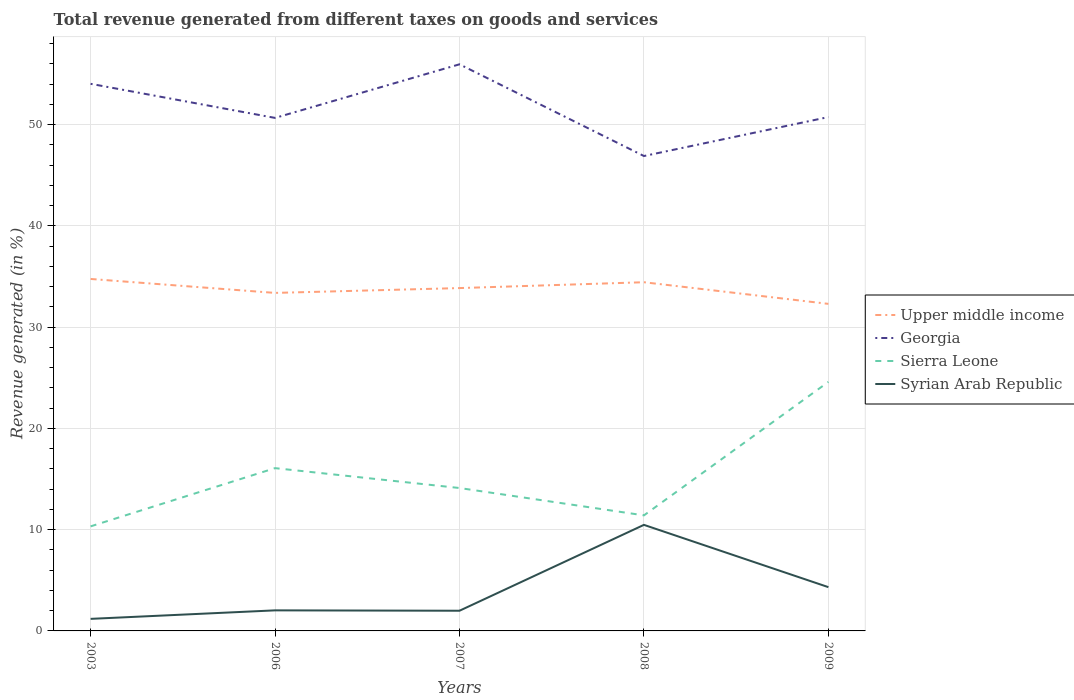Does the line corresponding to Sierra Leone intersect with the line corresponding to Georgia?
Give a very brief answer. No. Is the number of lines equal to the number of legend labels?
Offer a terse response. Yes. Across all years, what is the maximum total revenue generated in Georgia?
Your answer should be very brief. 46.89. In which year was the total revenue generated in Georgia maximum?
Keep it short and to the point. 2008. What is the total total revenue generated in Syrian Arab Republic in the graph?
Your answer should be compact. 0.04. What is the difference between the highest and the second highest total revenue generated in Upper middle income?
Provide a succinct answer. 2.46. How many years are there in the graph?
Offer a terse response. 5. Are the values on the major ticks of Y-axis written in scientific E-notation?
Give a very brief answer. No. Where does the legend appear in the graph?
Your response must be concise. Center right. What is the title of the graph?
Give a very brief answer. Total revenue generated from different taxes on goods and services. What is the label or title of the Y-axis?
Your answer should be compact. Revenue generated (in %). What is the Revenue generated (in %) of Upper middle income in 2003?
Give a very brief answer. 34.75. What is the Revenue generated (in %) of Georgia in 2003?
Ensure brevity in your answer.  54.02. What is the Revenue generated (in %) of Sierra Leone in 2003?
Offer a terse response. 10.32. What is the Revenue generated (in %) of Syrian Arab Republic in 2003?
Offer a terse response. 1.19. What is the Revenue generated (in %) of Upper middle income in 2006?
Your response must be concise. 33.38. What is the Revenue generated (in %) of Georgia in 2006?
Provide a short and direct response. 50.66. What is the Revenue generated (in %) of Sierra Leone in 2006?
Keep it short and to the point. 16.07. What is the Revenue generated (in %) of Syrian Arab Republic in 2006?
Your answer should be compact. 2.03. What is the Revenue generated (in %) of Upper middle income in 2007?
Ensure brevity in your answer.  33.85. What is the Revenue generated (in %) in Georgia in 2007?
Your answer should be very brief. 55.95. What is the Revenue generated (in %) in Sierra Leone in 2007?
Ensure brevity in your answer.  14.11. What is the Revenue generated (in %) in Syrian Arab Republic in 2007?
Provide a succinct answer. 1.99. What is the Revenue generated (in %) in Upper middle income in 2008?
Make the answer very short. 34.43. What is the Revenue generated (in %) of Georgia in 2008?
Your answer should be very brief. 46.89. What is the Revenue generated (in %) of Sierra Leone in 2008?
Offer a terse response. 11.41. What is the Revenue generated (in %) of Syrian Arab Republic in 2008?
Provide a short and direct response. 10.47. What is the Revenue generated (in %) in Upper middle income in 2009?
Offer a very short reply. 32.3. What is the Revenue generated (in %) in Georgia in 2009?
Your response must be concise. 50.74. What is the Revenue generated (in %) in Sierra Leone in 2009?
Give a very brief answer. 24.59. What is the Revenue generated (in %) of Syrian Arab Republic in 2009?
Your answer should be very brief. 4.32. Across all years, what is the maximum Revenue generated (in %) in Upper middle income?
Keep it short and to the point. 34.75. Across all years, what is the maximum Revenue generated (in %) in Georgia?
Your response must be concise. 55.95. Across all years, what is the maximum Revenue generated (in %) in Sierra Leone?
Your response must be concise. 24.59. Across all years, what is the maximum Revenue generated (in %) in Syrian Arab Republic?
Give a very brief answer. 10.47. Across all years, what is the minimum Revenue generated (in %) of Upper middle income?
Provide a short and direct response. 32.3. Across all years, what is the minimum Revenue generated (in %) in Georgia?
Offer a terse response. 46.89. Across all years, what is the minimum Revenue generated (in %) in Sierra Leone?
Your answer should be very brief. 10.32. Across all years, what is the minimum Revenue generated (in %) of Syrian Arab Republic?
Your response must be concise. 1.19. What is the total Revenue generated (in %) of Upper middle income in the graph?
Your answer should be very brief. 168.71. What is the total Revenue generated (in %) of Georgia in the graph?
Your answer should be compact. 258.27. What is the total Revenue generated (in %) in Sierra Leone in the graph?
Offer a terse response. 76.51. What is the total Revenue generated (in %) of Syrian Arab Republic in the graph?
Offer a very short reply. 20.01. What is the difference between the Revenue generated (in %) in Upper middle income in 2003 and that in 2006?
Give a very brief answer. 1.38. What is the difference between the Revenue generated (in %) of Georgia in 2003 and that in 2006?
Your answer should be very brief. 3.37. What is the difference between the Revenue generated (in %) of Sierra Leone in 2003 and that in 2006?
Give a very brief answer. -5.75. What is the difference between the Revenue generated (in %) of Syrian Arab Republic in 2003 and that in 2006?
Provide a short and direct response. -0.84. What is the difference between the Revenue generated (in %) of Upper middle income in 2003 and that in 2007?
Offer a terse response. 0.9. What is the difference between the Revenue generated (in %) of Georgia in 2003 and that in 2007?
Your response must be concise. -1.93. What is the difference between the Revenue generated (in %) of Sierra Leone in 2003 and that in 2007?
Your answer should be compact. -3.79. What is the difference between the Revenue generated (in %) in Syrian Arab Republic in 2003 and that in 2007?
Your answer should be very brief. -0.8. What is the difference between the Revenue generated (in %) of Upper middle income in 2003 and that in 2008?
Offer a terse response. 0.32. What is the difference between the Revenue generated (in %) of Georgia in 2003 and that in 2008?
Offer a terse response. 7.13. What is the difference between the Revenue generated (in %) of Sierra Leone in 2003 and that in 2008?
Your answer should be very brief. -1.09. What is the difference between the Revenue generated (in %) in Syrian Arab Republic in 2003 and that in 2008?
Ensure brevity in your answer.  -9.28. What is the difference between the Revenue generated (in %) in Upper middle income in 2003 and that in 2009?
Ensure brevity in your answer.  2.46. What is the difference between the Revenue generated (in %) of Georgia in 2003 and that in 2009?
Provide a succinct answer. 3.28. What is the difference between the Revenue generated (in %) in Sierra Leone in 2003 and that in 2009?
Provide a succinct answer. -14.27. What is the difference between the Revenue generated (in %) of Syrian Arab Republic in 2003 and that in 2009?
Keep it short and to the point. -3.13. What is the difference between the Revenue generated (in %) of Upper middle income in 2006 and that in 2007?
Provide a short and direct response. -0.48. What is the difference between the Revenue generated (in %) in Georgia in 2006 and that in 2007?
Ensure brevity in your answer.  -5.29. What is the difference between the Revenue generated (in %) of Sierra Leone in 2006 and that in 2007?
Your answer should be very brief. 1.96. What is the difference between the Revenue generated (in %) in Syrian Arab Republic in 2006 and that in 2007?
Your response must be concise. 0.04. What is the difference between the Revenue generated (in %) of Upper middle income in 2006 and that in 2008?
Offer a very short reply. -1.05. What is the difference between the Revenue generated (in %) in Georgia in 2006 and that in 2008?
Offer a terse response. 3.76. What is the difference between the Revenue generated (in %) in Sierra Leone in 2006 and that in 2008?
Make the answer very short. 4.66. What is the difference between the Revenue generated (in %) of Syrian Arab Republic in 2006 and that in 2008?
Ensure brevity in your answer.  -8.44. What is the difference between the Revenue generated (in %) of Upper middle income in 2006 and that in 2009?
Offer a very short reply. 1.08. What is the difference between the Revenue generated (in %) of Georgia in 2006 and that in 2009?
Make the answer very short. -0.08. What is the difference between the Revenue generated (in %) in Sierra Leone in 2006 and that in 2009?
Make the answer very short. -8.52. What is the difference between the Revenue generated (in %) in Syrian Arab Republic in 2006 and that in 2009?
Your answer should be compact. -2.29. What is the difference between the Revenue generated (in %) in Upper middle income in 2007 and that in 2008?
Offer a terse response. -0.58. What is the difference between the Revenue generated (in %) in Georgia in 2007 and that in 2008?
Offer a very short reply. 9.06. What is the difference between the Revenue generated (in %) in Sierra Leone in 2007 and that in 2008?
Your answer should be very brief. 2.7. What is the difference between the Revenue generated (in %) in Syrian Arab Republic in 2007 and that in 2008?
Give a very brief answer. -8.48. What is the difference between the Revenue generated (in %) of Upper middle income in 2007 and that in 2009?
Ensure brevity in your answer.  1.56. What is the difference between the Revenue generated (in %) of Georgia in 2007 and that in 2009?
Your answer should be compact. 5.21. What is the difference between the Revenue generated (in %) in Sierra Leone in 2007 and that in 2009?
Give a very brief answer. -10.48. What is the difference between the Revenue generated (in %) in Syrian Arab Republic in 2007 and that in 2009?
Offer a terse response. -2.33. What is the difference between the Revenue generated (in %) of Upper middle income in 2008 and that in 2009?
Ensure brevity in your answer.  2.14. What is the difference between the Revenue generated (in %) of Georgia in 2008 and that in 2009?
Make the answer very short. -3.85. What is the difference between the Revenue generated (in %) in Sierra Leone in 2008 and that in 2009?
Offer a very short reply. -13.18. What is the difference between the Revenue generated (in %) of Syrian Arab Republic in 2008 and that in 2009?
Give a very brief answer. 6.15. What is the difference between the Revenue generated (in %) of Upper middle income in 2003 and the Revenue generated (in %) of Georgia in 2006?
Your answer should be very brief. -15.9. What is the difference between the Revenue generated (in %) in Upper middle income in 2003 and the Revenue generated (in %) in Sierra Leone in 2006?
Provide a succinct answer. 18.68. What is the difference between the Revenue generated (in %) in Upper middle income in 2003 and the Revenue generated (in %) in Syrian Arab Republic in 2006?
Make the answer very short. 32.72. What is the difference between the Revenue generated (in %) of Georgia in 2003 and the Revenue generated (in %) of Sierra Leone in 2006?
Offer a terse response. 37.95. What is the difference between the Revenue generated (in %) in Georgia in 2003 and the Revenue generated (in %) in Syrian Arab Republic in 2006?
Ensure brevity in your answer.  51.99. What is the difference between the Revenue generated (in %) in Sierra Leone in 2003 and the Revenue generated (in %) in Syrian Arab Republic in 2006?
Your answer should be compact. 8.29. What is the difference between the Revenue generated (in %) in Upper middle income in 2003 and the Revenue generated (in %) in Georgia in 2007?
Keep it short and to the point. -21.2. What is the difference between the Revenue generated (in %) in Upper middle income in 2003 and the Revenue generated (in %) in Sierra Leone in 2007?
Make the answer very short. 20.64. What is the difference between the Revenue generated (in %) of Upper middle income in 2003 and the Revenue generated (in %) of Syrian Arab Republic in 2007?
Your answer should be very brief. 32.76. What is the difference between the Revenue generated (in %) of Georgia in 2003 and the Revenue generated (in %) of Sierra Leone in 2007?
Ensure brevity in your answer.  39.91. What is the difference between the Revenue generated (in %) in Georgia in 2003 and the Revenue generated (in %) in Syrian Arab Republic in 2007?
Offer a terse response. 52.03. What is the difference between the Revenue generated (in %) of Sierra Leone in 2003 and the Revenue generated (in %) of Syrian Arab Republic in 2007?
Your answer should be compact. 8.33. What is the difference between the Revenue generated (in %) of Upper middle income in 2003 and the Revenue generated (in %) of Georgia in 2008?
Your answer should be compact. -12.14. What is the difference between the Revenue generated (in %) in Upper middle income in 2003 and the Revenue generated (in %) in Sierra Leone in 2008?
Your answer should be very brief. 23.34. What is the difference between the Revenue generated (in %) in Upper middle income in 2003 and the Revenue generated (in %) in Syrian Arab Republic in 2008?
Keep it short and to the point. 24.28. What is the difference between the Revenue generated (in %) in Georgia in 2003 and the Revenue generated (in %) in Sierra Leone in 2008?
Provide a short and direct response. 42.61. What is the difference between the Revenue generated (in %) of Georgia in 2003 and the Revenue generated (in %) of Syrian Arab Republic in 2008?
Keep it short and to the point. 43.55. What is the difference between the Revenue generated (in %) of Sierra Leone in 2003 and the Revenue generated (in %) of Syrian Arab Republic in 2008?
Provide a short and direct response. -0.15. What is the difference between the Revenue generated (in %) in Upper middle income in 2003 and the Revenue generated (in %) in Georgia in 2009?
Offer a very short reply. -15.99. What is the difference between the Revenue generated (in %) of Upper middle income in 2003 and the Revenue generated (in %) of Sierra Leone in 2009?
Give a very brief answer. 10.16. What is the difference between the Revenue generated (in %) in Upper middle income in 2003 and the Revenue generated (in %) in Syrian Arab Republic in 2009?
Provide a short and direct response. 30.43. What is the difference between the Revenue generated (in %) in Georgia in 2003 and the Revenue generated (in %) in Sierra Leone in 2009?
Make the answer very short. 29.43. What is the difference between the Revenue generated (in %) of Georgia in 2003 and the Revenue generated (in %) of Syrian Arab Republic in 2009?
Make the answer very short. 49.7. What is the difference between the Revenue generated (in %) in Sierra Leone in 2003 and the Revenue generated (in %) in Syrian Arab Republic in 2009?
Keep it short and to the point. 6. What is the difference between the Revenue generated (in %) in Upper middle income in 2006 and the Revenue generated (in %) in Georgia in 2007?
Your response must be concise. -22.57. What is the difference between the Revenue generated (in %) in Upper middle income in 2006 and the Revenue generated (in %) in Sierra Leone in 2007?
Offer a terse response. 19.27. What is the difference between the Revenue generated (in %) of Upper middle income in 2006 and the Revenue generated (in %) of Syrian Arab Republic in 2007?
Provide a short and direct response. 31.38. What is the difference between the Revenue generated (in %) of Georgia in 2006 and the Revenue generated (in %) of Sierra Leone in 2007?
Ensure brevity in your answer.  36.55. What is the difference between the Revenue generated (in %) of Georgia in 2006 and the Revenue generated (in %) of Syrian Arab Republic in 2007?
Give a very brief answer. 48.66. What is the difference between the Revenue generated (in %) of Sierra Leone in 2006 and the Revenue generated (in %) of Syrian Arab Republic in 2007?
Provide a short and direct response. 14.08. What is the difference between the Revenue generated (in %) in Upper middle income in 2006 and the Revenue generated (in %) in Georgia in 2008?
Give a very brief answer. -13.52. What is the difference between the Revenue generated (in %) of Upper middle income in 2006 and the Revenue generated (in %) of Sierra Leone in 2008?
Give a very brief answer. 21.97. What is the difference between the Revenue generated (in %) in Upper middle income in 2006 and the Revenue generated (in %) in Syrian Arab Republic in 2008?
Your response must be concise. 22.9. What is the difference between the Revenue generated (in %) in Georgia in 2006 and the Revenue generated (in %) in Sierra Leone in 2008?
Your answer should be compact. 39.25. What is the difference between the Revenue generated (in %) in Georgia in 2006 and the Revenue generated (in %) in Syrian Arab Republic in 2008?
Ensure brevity in your answer.  40.18. What is the difference between the Revenue generated (in %) in Sierra Leone in 2006 and the Revenue generated (in %) in Syrian Arab Republic in 2008?
Offer a terse response. 5.6. What is the difference between the Revenue generated (in %) of Upper middle income in 2006 and the Revenue generated (in %) of Georgia in 2009?
Your answer should be compact. -17.36. What is the difference between the Revenue generated (in %) of Upper middle income in 2006 and the Revenue generated (in %) of Sierra Leone in 2009?
Provide a short and direct response. 8.79. What is the difference between the Revenue generated (in %) of Upper middle income in 2006 and the Revenue generated (in %) of Syrian Arab Republic in 2009?
Offer a very short reply. 29.05. What is the difference between the Revenue generated (in %) in Georgia in 2006 and the Revenue generated (in %) in Sierra Leone in 2009?
Your response must be concise. 26.07. What is the difference between the Revenue generated (in %) of Georgia in 2006 and the Revenue generated (in %) of Syrian Arab Republic in 2009?
Your answer should be very brief. 46.34. What is the difference between the Revenue generated (in %) of Sierra Leone in 2006 and the Revenue generated (in %) of Syrian Arab Republic in 2009?
Give a very brief answer. 11.75. What is the difference between the Revenue generated (in %) in Upper middle income in 2007 and the Revenue generated (in %) in Georgia in 2008?
Provide a short and direct response. -13.04. What is the difference between the Revenue generated (in %) in Upper middle income in 2007 and the Revenue generated (in %) in Sierra Leone in 2008?
Provide a short and direct response. 22.44. What is the difference between the Revenue generated (in %) of Upper middle income in 2007 and the Revenue generated (in %) of Syrian Arab Republic in 2008?
Provide a succinct answer. 23.38. What is the difference between the Revenue generated (in %) in Georgia in 2007 and the Revenue generated (in %) in Sierra Leone in 2008?
Keep it short and to the point. 44.54. What is the difference between the Revenue generated (in %) in Georgia in 2007 and the Revenue generated (in %) in Syrian Arab Republic in 2008?
Your answer should be very brief. 45.48. What is the difference between the Revenue generated (in %) of Sierra Leone in 2007 and the Revenue generated (in %) of Syrian Arab Republic in 2008?
Offer a terse response. 3.64. What is the difference between the Revenue generated (in %) in Upper middle income in 2007 and the Revenue generated (in %) in Georgia in 2009?
Offer a terse response. -16.89. What is the difference between the Revenue generated (in %) of Upper middle income in 2007 and the Revenue generated (in %) of Sierra Leone in 2009?
Give a very brief answer. 9.26. What is the difference between the Revenue generated (in %) in Upper middle income in 2007 and the Revenue generated (in %) in Syrian Arab Republic in 2009?
Make the answer very short. 29.53. What is the difference between the Revenue generated (in %) in Georgia in 2007 and the Revenue generated (in %) in Sierra Leone in 2009?
Keep it short and to the point. 31.36. What is the difference between the Revenue generated (in %) of Georgia in 2007 and the Revenue generated (in %) of Syrian Arab Republic in 2009?
Your answer should be very brief. 51.63. What is the difference between the Revenue generated (in %) of Sierra Leone in 2007 and the Revenue generated (in %) of Syrian Arab Republic in 2009?
Keep it short and to the point. 9.79. What is the difference between the Revenue generated (in %) in Upper middle income in 2008 and the Revenue generated (in %) in Georgia in 2009?
Your response must be concise. -16.31. What is the difference between the Revenue generated (in %) of Upper middle income in 2008 and the Revenue generated (in %) of Sierra Leone in 2009?
Ensure brevity in your answer.  9.84. What is the difference between the Revenue generated (in %) of Upper middle income in 2008 and the Revenue generated (in %) of Syrian Arab Republic in 2009?
Offer a terse response. 30.11. What is the difference between the Revenue generated (in %) of Georgia in 2008 and the Revenue generated (in %) of Sierra Leone in 2009?
Offer a very short reply. 22.3. What is the difference between the Revenue generated (in %) in Georgia in 2008 and the Revenue generated (in %) in Syrian Arab Republic in 2009?
Keep it short and to the point. 42.57. What is the difference between the Revenue generated (in %) of Sierra Leone in 2008 and the Revenue generated (in %) of Syrian Arab Republic in 2009?
Give a very brief answer. 7.09. What is the average Revenue generated (in %) of Upper middle income per year?
Your answer should be very brief. 33.74. What is the average Revenue generated (in %) in Georgia per year?
Provide a short and direct response. 51.65. What is the average Revenue generated (in %) of Sierra Leone per year?
Offer a terse response. 15.3. What is the average Revenue generated (in %) of Syrian Arab Republic per year?
Ensure brevity in your answer.  4. In the year 2003, what is the difference between the Revenue generated (in %) in Upper middle income and Revenue generated (in %) in Georgia?
Provide a short and direct response. -19.27. In the year 2003, what is the difference between the Revenue generated (in %) of Upper middle income and Revenue generated (in %) of Sierra Leone?
Make the answer very short. 24.43. In the year 2003, what is the difference between the Revenue generated (in %) in Upper middle income and Revenue generated (in %) in Syrian Arab Republic?
Your answer should be compact. 33.56. In the year 2003, what is the difference between the Revenue generated (in %) of Georgia and Revenue generated (in %) of Sierra Leone?
Make the answer very short. 43.7. In the year 2003, what is the difference between the Revenue generated (in %) of Georgia and Revenue generated (in %) of Syrian Arab Republic?
Your answer should be compact. 52.83. In the year 2003, what is the difference between the Revenue generated (in %) of Sierra Leone and Revenue generated (in %) of Syrian Arab Republic?
Offer a very short reply. 9.13. In the year 2006, what is the difference between the Revenue generated (in %) in Upper middle income and Revenue generated (in %) in Georgia?
Keep it short and to the point. -17.28. In the year 2006, what is the difference between the Revenue generated (in %) of Upper middle income and Revenue generated (in %) of Sierra Leone?
Your answer should be very brief. 17.3. In the year 2006, what is the difference between the Revenue generated (in %) of Upper middle income and Revenue generated (in %) of Syrian Arab Republic?
Offer a terse response. 31.35. In the year 2006, what is the difference between the Revenue generated (in %) of Georgia and Revenue generated (in %) of Sierra Leone?
Your answer should be compact. 34.58. In the year 2006, what is the difference between the Revenue generated (in %) of Georgia and Revenue generated (in %) of Syrian Arab Republic?
Provide a short and direct response. 48.63. In the year 2006, what is the difference between the Revenue generated (in %) in Sierra Leone and Revenue generated (in %) in Syrian Arab Republic?
Ensure brevity in your answer.  14.04. In the year 2007, what is the difference between the Revenue generated (in %) in Upper middle income and Revenue generated (in %) in Georgia?
Your answer should be compact. -22.1. In the year 2007, what is the difference between the Revenue generated (in %) of Upper middle income and Revenue generated (in %) of Sierra Leone?
Keep it short and to the point. 19.74. In the year 2007, what is the difference between the Revenue generated (in %) in Upper middle income and Revenue generated (in %) in Syrian Arab Republic?
Offer a very short reply. 31.86. In the year 2007, what is the difference between the Revenue generated (in %) in Georgia and Revenue generated (in %) in Sierra Leone?
Make the answer very short. 41.84. In the year 2007, what is the difference between the Revenue generated (in %) of Georgia and Revenue generated (in %) of Syrian Arab Republic?
Give a very brief answer. 53.96. In the year 2007, what is the difference between the Revenue generated (in %) of Sierra Leone and Revenue generated (in %) of Syrian Arab Republic?
Offer a terse response. 12.12. In the year 2008, what is the difference between the Revenue generated (in %) of Upper middle income and Revenue generated (in %) of Georgia?
Your response must be concise. -12.46. In the year 2008, what is the difference between the Revenue generated (in %) in Upper middle income and Revenue generated (in %) in Sierra Leone?
Your answer should be compact. 23.02. In the year 2008, what is the difference between the Revenue generated (in %) of Upper middle income and Revenue generated (in %) of Syrian Arab Republic?
Your response must be concise. 23.96. In the year 2008, what is the difference between the Revenue generated (in %) of Georgia and Revenue generated (in %) of Sierra Leone?
Keep it short and to the point. 35.48. In the year 2008, what is the difference between the Revenue generated (in %) in Georgia and Revenue generated (in %) in Syrian Arab Republic?
Keep it short and to the point. 36.42. In the year 2008, what is the difference between the Revenue generated (in %) of Sierra Leone and Revenue generated (in %) of Syrian Arab Republic?
Offer a terse response. 0.94. In the year 2009, what is the difference between the Revenue generated (in %) in Upper middle income and Revenue generated (in %) in Georgia?
Give a very brief answer. -18.44. In the year 2009, what is the difference between the Revenue generated (in %) in Upper middle income and Revenue generated (in %) in Sierra Leone?
Your response must be concise. 7.7. In the year 2009, what is the difference between the Revenue generated (in %) of Upper middle income and Revenue generated (in %) of Syrian Arab Republic?
Provide a succinct answer. 27.97. In the year 2009, what is the difference between the Revenue generated (in %) in Georgia and Revenue generated (in %) in Sierra Leone?
Make the answer very short. 26.15. In the year 2009, what is the difference between the Revenue generated (in %) in Georgia and Revenue generated (in %) in Syrian Arab Republic?
Offer a very short reply. 46.42. In the year 2009, what is the difference between the Revenue generated (in %) in Sierra Leone and Revenue generated (in %) in Syrian Arab Republic?
Offer a very short reply. 20.27. What is the ratio of the Revenue generated (in %) of Upper middle income in 2003 to that in 2006?
Your answer should be compact. 1.04. What is the ratio of the Revenue generated (in %) in Georgia in 2003 to that in 2006?
Your response must be concise. 1.07. What is the ratio of the Revenue generated (in %) of Sierra Leone in 2003 to that in 2006?
Keep it short and to the point. 0.64. What is the ratio of the Revenue generated (in %) in Syrian Arab Republic in 2003 to that in 2006?
Give a very brief answer. 0.59. What is the ratio of the Revenue generated (in %) of Upper middle income in 2003 to that in 2007?
Your answer should be compact. 1.03. What is the ratio of the Revenue generated (in %) of Georgia in 2003 to that in 2007?
Provide a succinct answer. 0.97. What is the ratio of the Revenue generated (in %) in Sierra Leone in 2003 to that in 2007?
Give a very brief answer. 0.73. What is the ratio of the Revenue generated (in %) in Syrian Arab Republic in 2003 to that in 2007?
Provide a succinct answer. 0.6. What is the ratio of the Revenue generated (in %) of Upper middle income in 2003 to that in 2008?
Your answer should be compact. 1.01. What is the ratio of the Revenue generated (in %) in Georgia in 2003 to that in 2008?
Provide a succinct answer. 1.15. What is the ratio of the Revenue generated (in %) of Sierra Leone in 2003 to that in 2008?
Your answer should be compact. 0.9. What is the ratio of the Revenue generated (in %) of Syrian Arab Republic in 2003 to that in 2008?
Your response must be concise. 0.11. What is the ratio of the Revenue generated (in %) in Upper middle income in 2003 to that in 2009?
Your answer should be compact. 1.08. What is the ratio of the Revenue generated (in %) in Georgia in 2003 to that in 2009?
Ensure brevity in your answer.  1.06. What is the ratio of the Revenue generated (in %) of Sierra Leone in 2003 to that in 2009?
Offer a very short reply. 0.42. What is the ratio of the Revenue generated (in %) in Syrian Arab Republic in 2003 to that in 2009?
Ensure brevity in your answer.  0.28. What is the ratio of the Revenue generated (in %) of Upper middle income in 2006 to that in 2007?
Your response must be concise. 0.99. What is the ratio of the Revenue generated (in %) in Georgia in 2006 to that in 2007?
Your response must be concise. 0.91. What is the ratio of the Revenue generated (in %) in Sierra Leone in 2006 to that in 2007?
Offer a very short reply. 1.14. What is the ratio of the Revenue generated (in %) in Syrian Arab Republic in 2006 to that in 2007?
Provide a succinct answer. 1.02. What is the ratio of the Revenue generated (in %) of Upper middle income in 2006 to that in 2008?
Offer a terse response. 0.97. What is the ratio of the Revenue generated (in %) in Georgia in 2006 to that in 2008?
Provide a succinct answer. 1.08. What is the ratio of the Revenue generated (in %) of Sierra Leone in 2006 to that in 2008?
Keep it short and to the point. 1.41. What is the ratio of the Revenue generated (in %) in Syrian Arab Republic in 2006 to that in 2008?
Offer a terse response. 0.19. What is the ratio of the Revenue generated (in %) in Upper middle income in 2006 to that in 2009?
Offer a terse response. 1.03. What is the ratio of the Revenue generated (in %) of Sierra Leone in 2006 to that in 2009?
Offer a terse response. 0.65. What is the ratio of the Revenue generated (in %) in Syrian Arab Republic in 2006 to that in 2009?
Your response must be concise. 0.47. What is the ratio of the Revenue generated (in %) in Upper middle income in 2007 to that in 2008?
Make the answer very short. 0.98. What is the ratio of the Revenue generated (in %) in Georgia in 2007 to that in 2008?
Keep it short and to the point. 1.19. What is the ratio of the Revenue generated (in %) of Sierra Leone in 2007 to that in 2008?
Ensure brevity in your answer.  1.24. What is the ratio of the Revenue generated (in %) of Syrian Arab Republic in 2007 to that in 2008?
Your response must be concise. 0.19. What is the ratio of the Revenue generated (in %) in Upper middle income in 2007 to that in 2009?
Your answer should be very brief. 1.05. What is the ratio of the Revenue generated (in %) in Georgia in 2007 to that in 2009?
Your answer should be compact. 1.1. What is the ratio of the Revenue generated (in %) of Sierra Leone in 2007 to that in 2009?
Provide a succinct answer. 0.57. What is the ratio of the Revenue generated (in %) of Syrian Arab Republic in 2007 to that in 2009?
Ensure brevity in your answer.  0.46. What is the ratio of the Revenue generated (in %) of Upper middle income in 2008 to that in 2009?
Give a very brief answer. 1.07. What is the ratio of the Revenue generated (in %) of Georgia in 2008 to that in 2009?
Give a very brief answer. 0.92. What is the ratio of the Revenue generated (in %) of Sierra Leone in 2008 to that in 2009?
Your response must be concise. 0.46. What is the ratio of the Revenue generated (in %) of Syrian Arab Republic in 2008 to that in 2009?
Provide a short and direct response. 2.42. What is the difference between the highest and the second highest Revenue generated (in %) in Upper middle income?
Offer a terse response. 0.32. What is the difference between the highest and the second highest Revenue generated (in %) of Georgia?
Make the answer very short. 1.93. What is the difference between the highest and the second highest Revenue generated (in %) in Sierra Leone?
Offer a very short reply. 8.52. What is the difference between the highest and the second highest Revenue generated (in %) of Syrian Arab Republic?
Ensure brevity in your answer.  6.15. What is the difference between the highest and the lowest Revenue generated (in %) of Upper middle income?
Your answer should be very brief. 2.46. What is the difference between the highest and the lowest Revenue generated (in %) in Georgia?
Your answer should be very brief. 9.06. What is the difference between the highest and the lowest Revenue generated (in %) in Sierra Leone?
Give a very brief answer. 14.27. What is the difference between the highest and the lowest Revenue generated (in %) in Syrian Arab Republic?
Your answer should be compact. 9.28. 